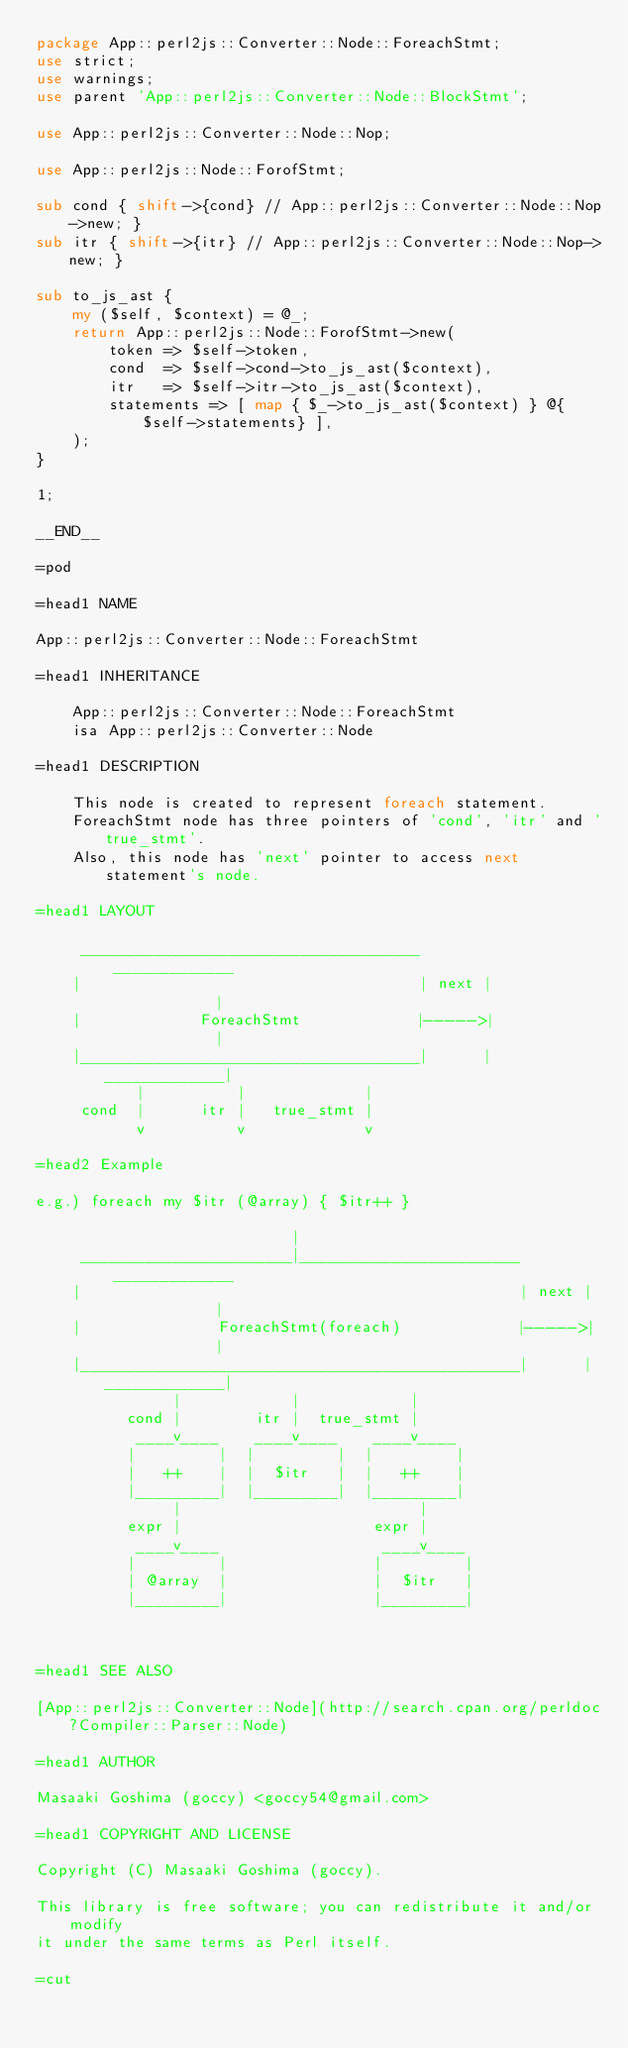Convert code to text. <code><loc_0><loc_0><loc_500><loc_500><_Perl_>package App::perl2js::Converter::Node::ForeachStmt;
use strict;
use warnings;
use parent 'App::perl2js::Converter::Node::BlockStmt';

use App::perl2js::Converter::Node::Nop;

use App::perl2js::Node::ForofStmt;

sub cond { shift->{cond} // App::perl2js::Converter::Node::Nop->new; }
sub itr { shift->{itr} // App::perl2js::Converter::Node::Nop->new; }

sub to_js_ast {
    my ($self, $context) = @_;
    return App::perl2js::Node::ForofStmt->new(
        token => $self->token,
        cond  => $self->cond->to_js_ast($context),
        itr   => $self->itr->to_js_ast($context),
        statements => [ map { $_->to_js_ast($context) } @{$self->statements} ],
    );
}

1;

__END__

=pod

=head1 NAME

App::perl2js::Converter::Node::ForeachStmt

=head1 INHERITANCE

    App::perl2js::Converter::Node::ForeachStmt
    isa App::perl2js::Converter::Node

=head1 DESCRIPTION

    This node is created to represent foreach statement.
    ForeachStmt node has three pointers of 'cond', 'itr' and 'true_stmt'.
    Also, this node has 'next' pointer to access next statement's node.

=head1 LAYOUT

     _____________________________________        _____________
    |                                     | next |             |
    |             ForeachStmt             |----->|             |
    |_____________________________________|      |_____________|
           |          |             |
     cond  |      itr |   true_stmt |
           v          v             v

=head2 Example

e.g.) foreach my $itr (@array) { $itr++ }

                            |
     _______________________|________________________        _____________
    |                                                | next |             |
    |               ForeachStmt(foreach)             |----->|             |
    |________________________________________________|      |_____________|
               |            |            |
          cond |        itr |  true_stmt |
           ____v____    ____v____    ____v____
          |         |  |         |  |         |
          |   ++    |  |  $itr   |  |   ++    |
          |_________|  |_________|  |_________|
               |                          |
          expr |                     expr |
           ____v____                  ____v____
          |         |                |         |
          | @array  |                |  $itr   |
          |_________|                |_________|



=head1 SEE ALSO

[App::perl2js::Converter::Node](http://search.cpan.org/perldoc?Compiler::Parser::Node)

=head1 AUTHOR

Masaaki Goshima (goccy) <goccy54@gmail.com>

=head1 COPYRIGHT AND LICENSE

Copyright (C) Masaaki Goshima (goccy).

This library is free software; you can redistribute it and/or modify
it under the same terms as Perl itself.

=cut
</code> 